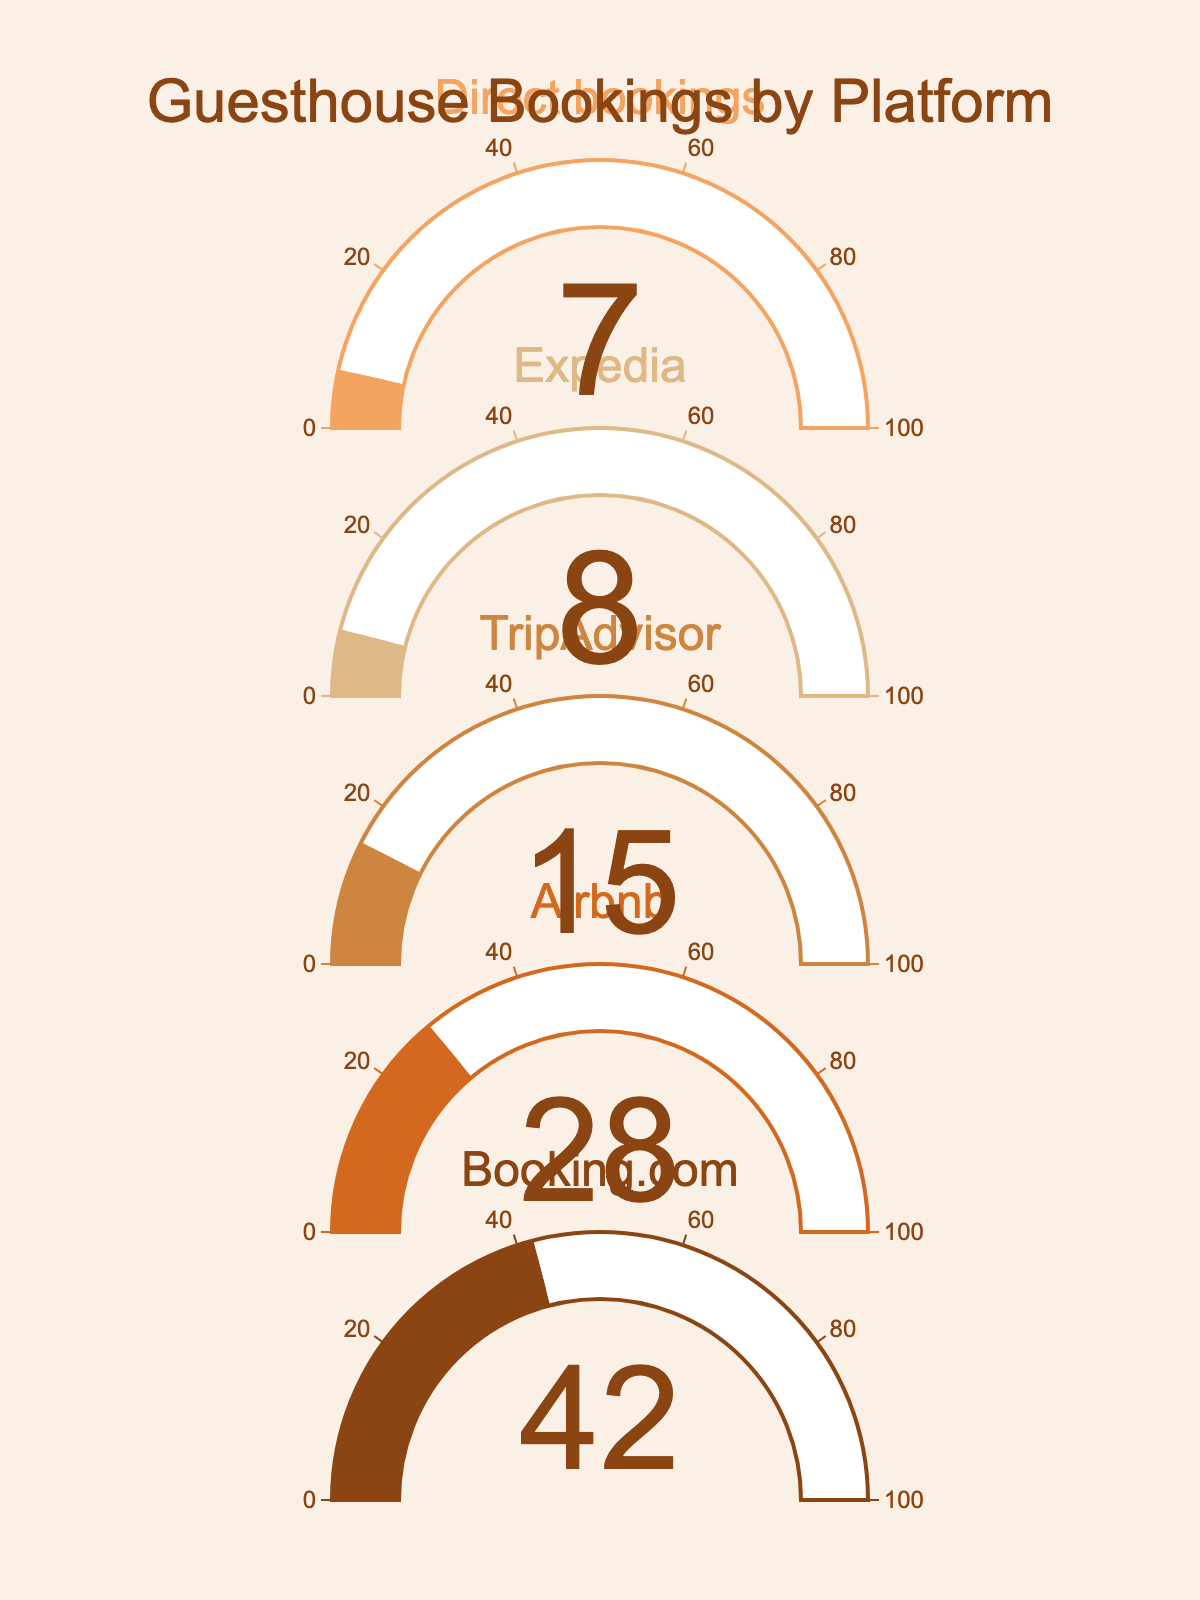What is the title of the plot? The title of the plot is located at the top of the figure and typically summarizes the data being displayed.
Answer: Guesthouse Bookings by Platform Which platform has the highest percentage of bookings? By looking at the gauge values, Booking.com has the highest percentage.
Answer: Booking.com What is the percentage of bookings made through TripAdvisor? The gauge for TripAdvisor shows a value representing its percentage.
Answer: 15% How much higher is the Booking.com percentage compared to Airbnb? Booking.com has 42% and Airbnb has 28%, so the difference is 42 - 28.
Answer: 14% What is the total percentage of bookings made through third-party platforms (Booking.com, Airbnb, TripAdvisor, Expedia)? Add the percentages of Booking.com, Airbnb, TripAdvisor, and Expedia which are 42%, 28%, 15%, and 8% respectively (42 + 28 + 15 + 8).
Answer: 93% Which platform has the lowest percentage of bookings? The platform with the smallest gauge value represents the lowest percentage.
Answer: Direct bookings Are direct bookings higher or lower than Expedia bookings? Comparing the percentage values of direct bookings (7%) and Expedia (8%) shows that direct bookings are lower.
Answer: Lower How much do Booking.com and Airbnb contribute to the total percentage of bookings? Add the percentages of Booking.com and Airbnb (42 + 28).
Answer: 70% What is the average percentage of bookings among all platforms? Sum all the percentages (42 + 28 + 15 + 8 + 7 = 100) and divide by the number of platforms (5).
Answer: 20% How many platforms have a percentage of bookings below 20%? Analyzing the gauge values for TripAdvisor (15%), Expedia (8%), and Direct bookings (7%) reveals three platforms below 20%.
Answer: 3 